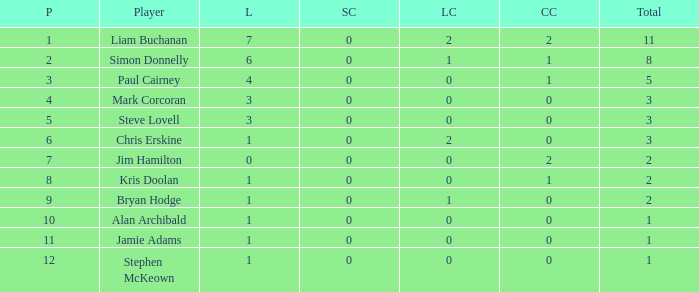What was the lowest number of points scored in the league cup? 0.0. 